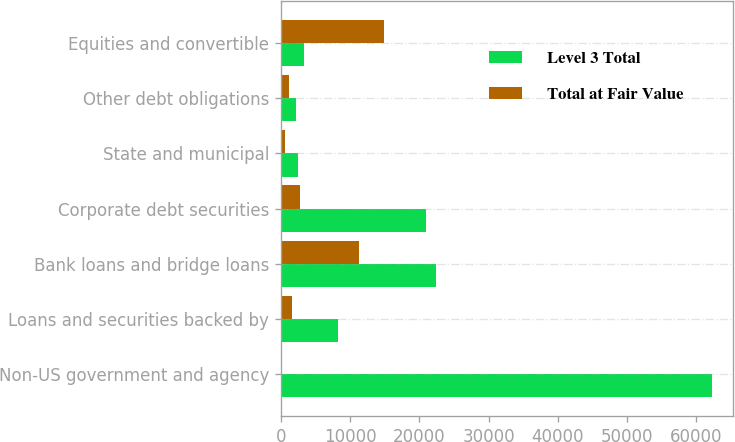Convert chart. <chart><loc_0><loc_0><loc_500><loc_500><stacked_bar_chart><ecel><fcel>Non-US government and agency<fcel>Loans and securities backed by<fcel>Bank loans and bridge loans<fcel>Corporate debt securities<fcel>State and municipal<fcel>Other debt obligations<fcel>Equities and convertible<nl><fcel>Level 3 Total<fcel>62250<fcel>8216<fcel>22407<fcel>20981<fcel>2477<fcel>2251<fcel>3389<nl><fcel>Total at Fair Value<fcel>26<fcel>1619<fcel>11235<fcel>2821<fcel>619<fcel>1185<fcel>14855<nl></chart> 